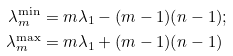Convert formula to latex. <formula><loc_0><loc_0><loc_500><loc_500>\lambda _ { m } ^ { \min } & = m \lambda _ { 1 } - ( m - 1 ) ( n - 1 ) ; \\ \lambda _ { m } ^ { \max } & = m \lambda _ { 1 } + ( m - 1 ) ( n - 1 )</formula> 